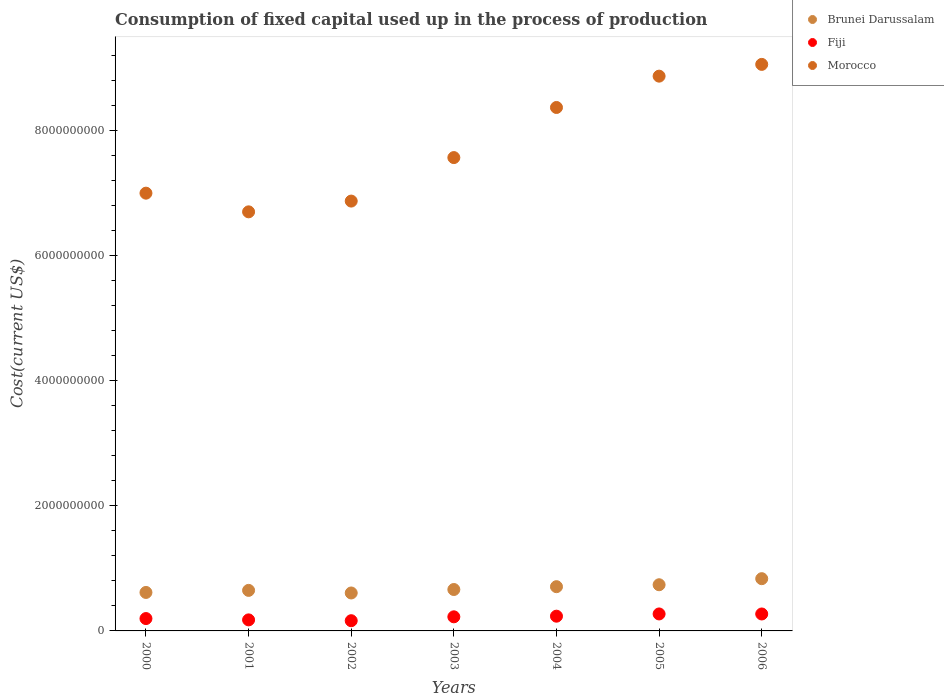How many different coloured dotlines are there?
Offer a terse response. 3. What is the amount consumed in the process of production in Morocco in 2005?
Your response must be concise. 8.88e+09. Across all years, what is the maximum amount consumed in the process of production in Fiji?
Provide a succinct answer. 2.72e+08. Across all years, what is the minimum amount consumed in the process of production in Fiji?
Provide a succinct answer. 1.63e+08. What is the total amount consumed in the process of production in Brunei Darussalam in the graph?
Make the answer very short. 4.82e+09. What is the difference between the amount consumed in the process of production in Brunei Darussalam in 2000 and that in 2004?
Give a very brief answer. -9.22e+07. What is the difference between the amount consumed in the process of production in Fiji in 2003 and the amount consumed in the process of production in Morocco in 2001?
Provide a short and direct response. -6.48e+09. What is the average amount consumed in the process of production in Morocco per year?
Give a very brief answer. 7.78e+09. In the year 2004, what is the difference between the amount consumed in the process of production in Brunei Darussalam and amount consumed in the process of production in Morocco?
Your answer should be compact. -7.67e+09. What is the ratio of the amount consumed in the process of production in Fiji in 2003 to that in 2006?
Your answer should be compact. 0.83. Is the amount consumed in the process of production in Brunei Darussalam in 2001 less than that in 2005?
Provide a short and direct response. Yes. Is the difference between the amount consumed in the process of production in Brunei Darussalam in 2001 and 2002 greater than the difference between the amount consumed in the process of production in Morocco in 2001 and 2002?
Offer a very short reply. Yes. What is the difference between the highest and the second highest amount consumed in the process of production in Brunei Darussalam?
Your response must be concise. 9.71e+07. What is the difference between the highest and the lowest amount consumed in the process of production in Brunei Darussalam?
Offer a very short reply. 2.29e+08. In how many years, is the amount consumed in the process of production in Brunei Darussalam greater than the average amount consumed in the process of production in Brunei Darussalam taken over all years?
Offer a terse response. 3. Is it the case that in every year, the sum of the amount consumed in the process of production in Fiji and amount consumed in the process of production in Brunei Darussalam  is greater than the amount consumed in the process of production in Morocco?
Ensure brevity in your answer.  No. Does the amount consumed in the process of production in Brunei Darussalam monotonically increase over the years?
Your answer should be compact. No. How many dotlines are there?
Keep it short and to the point. 3. How many years are there in the graph?
Give a very brief answer. 7. What is the difference between two consecutive major ticks on the Y-axis?
Make the answer very short. 2.00e+09. Are the values on the major ticks of Y-axis written in scientific E-notation?
Ensure brevity in your answer.  No. Does the graph contain any zero values?
Make the answer very short. No. Does the graph contain grids?
Provide a succinct answer. No. Where does the legend appear in the graph?
Offer a very short reply. Top right. How many legend labels are there?
Your response must be concise. 3. How are the legend labels stacked?
Provide a short and direct response. Vertical. What is the title of the graph?
Your answer should be very brief. Consumption of fixed capital used up in the process of production. What is the label or title of the Y-axis?
Make the answer very short. Cost(current US$). What is the Cost(current US$) in Brunei Darussalam in 2000?
Your answer should be very brief. 6.16e+08. What is the Cost(current US$) in Fiji in 2000?
Provide a succinct answer. 1.98e+08. What is the Cost(current US$) of Morocco in 2000?
Make the answer very short. 7.00e+09. What is the Cost(current US$) of Brunei Darussalam in 2001?
Provide a succinct answer. 6.49e+08. What is the Cost(current US$) of Fiji in 2001?
Make the answer very short. 1.77e+08. What is the Cost(current US$) of Morocco in 2001?
Provide a short and direct response. 6.71e+09. What is the Cost(current US$) of Brunei Darussalam in 2002?
Your answer should be very brief. 6.07e+08. What is the Cost(current US$) of Fiji in 2002?
Offer a terse response. 1.63e+08. What is the Cost(current US$) of Morocco in 2002?
Give a very brief answer. 6.88e+09. What is the Cost(current US$) in Brunei Darussalam in 2003?
Your response must be concise. 6.63e+08. What is the Cost(current US$) of Fiji in 2003?
Keep it short and to the point. 2.26e+08. What is the Cost(current US$) of Morocco in 2003?
Ensure brevity in your answer.  7.57e+09. What is the Cost(current US$) in Brunei Darussalam in 2004?
Keep it short and to the point. 7.08e+08. What is the Cost(current US$) in Fiji in 2004?
Provide a short and direct response. 2.36e+08. What is the Cost(current US$) in Morocco in 2004?
Give a very brief answer. 8.38e+09. What is the Cost(current US$) in Brunei Darussalam in 2005?
Keep it short and to the point. 7.39e+08. What is the Cost(current US$) in Fiji in 2005?
Your answer should be very brief. 2.72e+08. What is the Cost(current US$) of Morocco in 2005?
Provide a succinct answer. 8.88e+09. What is the Cost(current US$) in Brunei Darussalam in 2006?
Offer a very short reply. 8.36e+08. What is the Cost(current US$) in Fiji in 2006?
Keep it short and to the point. 2.71e+08. What is the Cost(current US$) of Morocco in 2006?
Make the answer very short. 9.07e+09. Across all years, what is the maximum Cost(current US$) of Brunei Darussalam?
Your response must be concise. 8.36e+08. Across all years, what is the maximum Cost(current US$) in Fiji?
Provide a succinct answer. 2.72e+08. Across all years, what is the maximum Cost(current US$) of Morocco?
Make the answer very short. 9.07e+09. Across all years, what is the minimum Cost(current US$) of Brunei Darussalam?
Offer a very short reply. 6.07e+08. Across all years, what is the minimum Cost(current US$) in Fiji?
Your response must be concise. 1.63e+08. Across all years, what is the minimum Cost(current US$) of Morocco?
Provide a succinct answer. 6.71e+09. What is the total Cost(current US$) in Brunei Darussalam in the graph?
Give a very brief answer. 4.82e+09. What is the total Cost(current US$) in Fiji in the graph?
Give a very brief answer. 1.54e+09. What is the total Cost(current US$) of Morocco in the graph?
Ensure brevity in your answer.  5.45e+1. What is the difference between the Cost(current US$) in Brunei Darussalam in 2000 and that in 2001?
Your response must be concise. -3.31e+07. What is the difference between the Cost(current US$) of Fiji in 2000 and that in 2001?
Provide a succinct answer. 2.11e+07. What is the difference between the Cost(current US$) in Morocco in 2000 and that in 2001?
Your answer should be compact. 2.99e+08. What is the difference between the Cost(current US$) of Brunei Darussalam in 2000 and that in 2002?
Provide a succinct answer. 8.53e+06. What is the difference between the Cost(current US$) of Fiji in 2000 and that in 2002?
Offer a very short reply. 3.44e+07. What is the difference between the Cost(current US$) of Morocco in 2000 and that in 2002?
Give a very brief answer. 1.27e+08. What is the difference between the Cost(current US$) of Brunei Darussalam in 2000 and that in 2003?
Offer a very short reply. -4.70e+07. What is the difference between the Cost(current US$) of Fiji in 2000 and that in 2003?
Your answer should be very brief. -2.79e+07. What is the difference between the Cost(current US$) in Morocco in 2000 and that in 2003?
Your answer should be very brief. -5.69e+08. What is the difference between the Cost(current US$) in Brunei Darussalam in 2000 and that in 2004?
Keep it short and to the point. -9.22e+07. What is the difference between the Cost(current US$) of Fiji in 2000 and that in 2004?
Give a very brief answer. -3.80e+07. What is the difference between the Cost(current US$) of Morocco in 2000 and that in 2004?
Make the answer very short. -1.37e+09. What is the difference between the Cost(current US$) in Brunei Darussalam in 2000 and that in 2005?
Your response must be concise. -1.23e+08. What is the difference between the Cost(current US$) of Fiji in 2000 and that in 2005?
Your answer should be very brief. -7.39e+07. What is the difference between the Cost(current US$) of Morocco in 2000 and that in 2005?
Your answer should be very brief. -1.87e+09. What is the difference between the Cost(current US$) of Brunei Darussalam in 2000 and that in 2006?
Provide a short and direct response. -2.20e+08. What is the difference between the Cost(current US$) of Fiji in 2000 and that in 2006?
Offer a very short reply. -7.33e+07. What is the difference between the Cost(current US$) in Morocco in 2000 and that in 2006?
Keep it short and to the point. -2.06e+09. What is the difference between the Cost(current US$) in Brunei Darussalam in 2001 and that in 2002?
Offer a very short reply. 4.16e+07. What is the difference between the Cost(current US$) of Fiji in 2001 and that in 2002?
Your answer should be very brief. 1.33e+07. What is the difference between the Cost(current US$) of Morocco in 2001 and that in 2002?
Make the answer very short. -1.72e+08. What is the difference between the Cost(current US$) in Brunei Darussalam in 2001 and that in 2003?
Make the answer very short. -1.40e+07. What is the difference between the Cost(current US$) in Fiji in 2001 and that in 2003?
Your response must be concise. -4.89e+07. What is the difference between the Cost(current US$) of Morocco in 2001 and that in 2003?
Provide a short and direct response. -8.68e+08. What is the difference between the Cost(current US$) of Brunei Darussalam in 2001 and that in 2004?
Offer a terse response. -5.92e+07. What is the difference between the Cost(current US$) in Fiji in 2001 and that in 2004?
Ensure brevity in your answer.  -5.91e+07. What is the difference between the Cost(current US$) in Morocco in 2001 and that in 2004?
Give a very brief answer. -1.67e+09. What is the difference between the Cost(current US$) in Brunei Darussalam in 2001 and that in 2005?
Your answer should be compact. -9.01e+07. What is the difference between the Cost(current US$) of Fiji in 2001 and that in 2005?
Ensure brevity in your answer.  -9.49e+07. What is the difference between the Cost(current US$) in Morocco in 2001 and that in 2005?
Your answer should be very brief. -2.17e+09. What is the difference between the Cost(current US$) in Brunei Darussalam in 2001 and that in 2006?
Offer a very short reply. -1.87e+08. What is the difference between the Cost(current US$) of Fiji in 2001 and that in 2006?
Keep it short and to the point. -9.44e+07. What is the difference between the Cost(current US$) in Morocco in 2001 and that in 2006?
Provide a short and direct response. -2.36e+09. What is the difference between the Cost(current US$) of Brunei Darussalam in 2002 and that in 2003?
Ensure brevity in your answer.  -5.56e+07. What is the difference between the Cost(current US$) of Fiji in 2002 and that in 2003?
Offer a very short reply. -6.22e+07. What is the difference between the Cost(current US$) of Morocco in 2002 and that in 2003?
Provide a short and direct response. -6.96e+08. What is the difference between the Cost(current US$) in Brunei Darussalam in 2002 and that in 2004?
Offer a terse response. -1.01e+08. What is the difference between the Cost(current US$) in Fiji in 2002 and that in 2004?
Provide a short and direct response. -7.24e+07. What is the difference between the Cost(current US$) in Morocco in 2002 and that in 2004?
Ensure brevity in your answer.  -1.50e+09. What is the difference between the Cost(current US$) of Brunei Darussalam in 2002 and that in 2005?
Make the answer very short. -1.32e+08. What is the difference between the Cost(current US$) in Fiji in 2002 and that in 2005?
Your response must be concise. -1.08e+08. What is the difference between the Cost(current US$) in Morocco in 2002 and that in 2005?
Your answer should be very brief. -2.00e+09. What is the difference between the Cost(current US$) of Brunei Darussalam in 2002 and that in 2006?
Your answer should be very brief. -2.29e+08. What is the difference between the Cost(current US$) of Fiji in 2002 and that in 2006?
Keep it short and to the point. -1.08e+08. What is the difference between the Cost(current US$) in Morocco in 2002 and that in 2006?
Provide a succinct answer. -2.19e+09. What is the difference between the Cost(current US$) of Brunei Darussalam in 2003 and that in 2004?
Offer a very short reply. -4.52e+07. What is the difference between the Cost(current US$) in Fiji in 2003 and that in 2004?
Make the answer very short. -1.02e+07. What is the difference between the Cost(current US$) of Morocco in 2003 and that in 2004?
Make the answer very short. -8.02e+08. What is the difference between the Cost(current US$) of Brunei Darussalam in 2003 and that in 2005?
Your answer should be compact. -7.62e+07. What is the difference between the Cost(current US$) of Fiji in 2003 and that in 2005?
Give a very brief answer. -4.60e+07. What is the difference between the Cost(current US$) in Morocco in 2003 and that in 2005?
Your answer should be very brief. -1.30e+09. What is the difference between the Cost(current US$) of Brunei Darussalam in 2003 and that in 2006?
Give a very brief answer. -1.73e+08. What is the difference between the Cost(current US$) in Fiji in 2003 and that in 2006?
Provide a short and direct response. -4.55e+07. What is the difference between the Cost(current US$) in Morocco in 2003 and that in 2006?
Your answer should be compact. -1.49e+09. What is the difference between the Cost(current US$) of Brunei Darussalam in 2004 and that in 2005?
Give a very brief answer. -3.10e+07. What is the difference between the Cost(current US$) of Fiji in 2004 and that in 2005?
Offer a terse response. -3.58e+07. What is the difference between the Cost(current US$) of Morocco in 2004 and that in 2005?
Ensure brevity in your answer.  -5.01e+08. What is the difference between the Cost(current US$) in Brunei Darussalam in 2004 and that in 2006?
Your answer should be compact. -1.28e+08. What is the difference between the Cost(current US$) in Fiji in 2004 and that in 2006?
Your response must be concise. -3.53e+07. What is the difference between the Cost(current US$) of Morocco in 2004 and that in 2006?
Provide a short and direct response. -6.90e+08. What is the difference between the Cost(current US$) of Brunei Darussalam in 2005 and that in 2006?
Offer a very short reply. -9.71e+07. What is the difference between the Cost(current US$) of Fiji in 2005 and that in 2006?
Keep it short and to the point. 5.63e+05. What is the difference between the Cost(current US$) of Morocco in 2005 and that in 2006?
Keep it short and to the point. -1.88e+08. What is the difference between the Cost(current US$) of Brunei Darussalam in 2000 and the Cost(current US$) of Fiji in 2001?
Keep it short and to the point. 4.39e+08. What is the difference between the Cost(current US$) of Brunei Darussalam in 2000 and the Cost(current US$) of Morocco in 2001?
Your response must be concise. -6.09e+09. What is the difference between the Cost(current US$) of Fiji in 2000 and the Cost(current US$) of Morocco in 2001?
Give a very brief answer. -6.51e+09. What is the difference between the Cost(current US$) of Brunei Darussalam in 2000 and the Cost(current US$) of Fiji in 2002?
Give a very brief answer. 4.52e+08. What is the difference between the Cost(current US$) of Brunei Darussalam in 2000 and the Cost(current US$) of Morocco in 2002?
Ensure brevity in your answer.  -6.26e+09. What is the difference between the Cost(current US$) of Fiji in 2000 and the Cost(current US$) of Morocco in 2002?
Your answer should be compact. -6.68e+09. What is the difference between the Cost(current US$) of Brunei Darussalam in 2000 and the Cost(current US$) of Fiji in 2003?
Give a very brief answer. 3.90e+08. What is the difference between the Cost(current US$) in Brunei Darussalam in 2000 and the Cost(current US$) in Morocco in 2003?
Offer a terse response. -6.96e+09. What is the difference between the Cost(current US$) of Fiji in 2000 and the Cost(current US$) of Morocco in 2003?
Provide a succinct answer. -7.38e+09. What is the difference between the Cost(current US$) in Brunei Darussalam in 2000 and the Cost(current US$) in Fiji in 2004?
Keep it short and to the point. 3.80e+08. What is the difference between the Cost(current US$) of Brunei Darussalam in 2000 and the Cost(current US$) of Morocco in 2004?
Keep it short and to the point. -7.76e+09. What is the difference between the Cost(current US$) in Fiji in 2000 and the Cost(current US$) in Morocco in 2004?
Make the answer very short. -8.18e+09. What is the difference between the Cost(current US$) in Brunei Darussalam in 2000 and the Cost(current US$) in Fiji in 2005?
Provide a succinct answer. 3.44e+08. What is the difference between the Cost(current US$) of Brunei Darussalam in 2000 and the Cost(current US$) of Morocco in 2005?
Offer a terse response. -8.26e+09. What is the difference between the Cost(current US$) of Fiji in 2000 and the Cost(current US$) of Morocco in 2005?
Your answer should be very brief. -8.68e+09. What is the difference between the Cost(current US$) in Brunei Darussalam in 2000 and the Cost(current US$) in Fiji in 2006?
Offer a very short reply. 3.45e+08. What is the difference between the Cost(current US$) in Brunei Darussalam in 2000 and the Cost(current US$) in Morocco in 2006?
Offer a very short reply. -8.45e+09. What is the difference between the Cost(current US$) of Fiji in 2000 and the Cost(current US$) of Morocco in 2006?
Provide a short and direct response. -8.87e+09. What is the difference between the Cost(current US$) of Brunei Darussalam in 2001 and the Cost(current US$) of Fiji in 2002?
Offer a terse response. 4.85e+08. What is the difference between the Cost(current US$) in Brunei Darussalam in 2001 and the Cost(current US$) in Morocco in 2002?
Your response must be concise. -6.23e+09. What is the difference between the Cost(current US$) of Fiji in 2001 and the Cost(current US$) of Morocco in 2002?
Offer a terse response. -6.70e+09. What is the difference between the Cost(current US$) in Brunei Darussalam in 2001 and the Cost(current US$) in Fiji in 2003?
Ensure brevity in your answer.  4.23e+08. What is the difference between the Cost(current US$) in Brunei Darussalam in 2001 and the Cost(current US$) in Morocco in 2003?
Give a very brief answer. -6.93e+09. What is the difference between the Cost(current US$) in Fiji in 2001 and the Cost(current US$) in Morocco in 2003?
Provide a short and direct response. -7.40e+09. What is the difference between the Cost(current US$) of Brunei Darussalam in 2001 and the Cost(current US$) of Fiji in 2004?
Give a very brief answer. 4.13e+08. What is the difference between the Cost(current US$) of Brunei Darussalam in 2001 and the Cost(current US$) of Morocco in 2004?
Your answer should be compact. -7.73e+09. What is the difference between the Cost(current US$) in Fiji in 2001 and the Cost(current US$) in Morocco in 2004?
Give a very brief answer. -8.20e+09. What is the difference between the Cost(current US$) in Brunei Darussalam in 2001 and the Cost(current US$) in Fiji in 2005?
Offer a terse response. 3.77e+08. What is the difference between the Cost(current US$) in Brunei Darussalam in 2001 and the Cost(current US$) in Morocco in 2005?
Provide a short and direct response. -8.23e+09. What is the difference between the Cost(current US$) in Fiji in 2001 and the Cost(current US$) in Morocco in 2005?
Provide a succinct answer. -8.70e+09. What is the difference between the Cost(current US$) in Brunei Darussalam in 2001 and the Cost(current US$) in Fiji in 2006?
Ensure brevity in your answer.  3.78e+08. What is the difference between the Cost(current US$) in Brunei Darussalam in 2001 and the Cost(current US$) in Morocco in 2006?
Your answer should be very brief. -8.42e+09. What is the difference between the Cost(current US$) in Fiji in 2001 and the Cost(current US$) in Morocco in 2006?
Give a very brief answer. -8.89e+09. What is the difference between the Cost(current US$) in Brunei Darussalam in 2002 and the Cost(current US$) in Fiji in 2003?
Give a very brief answer. 3.81e+08. What is the difference between the Cost(current US$) in Brunei Darussalam in 2002 and the Cost(current US$) in Morocco in 2003?
Your response must be concise. -6.97e+09. What is the difference between the Cost(current US$) of Fiji in 2002 and the Cost(current US$) of Morocco in 2003?
Give a very brief answer. -7.41e+09. What is the difference between the Cost(current US$) in Brunei Darussalam in 2002 and the Cost(current US$) in Fiji in 2004?
Provide a short and direct response. 3.71e+08. What is the difference between the Cost(current US$) in Brunei Darussalam in 2002 and the Cost(current US$) in Morocco in 2004?
Provide a short and direct response. -7.77e+09. What is the difference between the Cost(current US$) in Fiji in 2002 and the Cost(current US$) in Morocco in 2004?
Keep it short and to the point. -8.21e+09. What is the difference between the Cost(current US$) in Brunei Darussalam in 2002 and the Cost(current US$) in Fiji in 2005?
Offer a very short reply. 3.35e+08. What is the difference between the Cost(current US$) of Brunei Darussalam in 2002 and the Cost(current US$) of Morocco in 2005?
Provide a short and direct response. -8.27e+09. What is the difference between the Cost(current US$) of Fiji in 2002 and the Cost(current US$) of Morocco in 2005?
Provide a succinct answer. -8.71e+09. What is the difference between the Cost(current US$) in Brunei Darussalam in 2002 and the Cost(current US$) in Fiji in 2006?
Your answer should be compact. 3.36e+08. What is the difference between the Cost(current US$) of Brunei Darussalam in 2002 and the Cost(current US$) of Morocco in 2006?
Make the answer very short. -8.46e+09. What is the difference between the Cost(current US$) of Fiji in 2002 and the Cost(current US$) of Morocco in 2006?
Give a very brief answer. -8.90e+09. What is the difference between the Cost(current US$) of Brunei Darussalam in 2003 and the Cost(current US$) of Fiji in 2004?
Your answer should be very brief. 4.27e+08. What is the difference between the Cost(current US$) of Brunei Darussalam in 2003 and the Cost(current US$) of Morocco in 2004?
Ensure brevity in your answer.  -7.71e+09. What is the difference between the Cost(current US$) of Fiji in 2003 and the Cost(current US$) of Morocco in 2004?
Your answer should be very brief. -8.15e+09. What is the difference between the Cost(current US$) of Brunei Darussalam in 2003 and the Cost(current US$) of Fiji in 2005?
Offer a very short reply. 3.91e+08. What is the difference between the Cost(current US$) of Brunei Darussalam in 2003 and the Cost(current US$) of Morocco in 2005?
Provide a short and direct response. -8.21e+09. What is the difference between the Cost(current US$) of Fiji in 2003 and the Cost(current US$) of Morocco in 2005?
Provide a succinct answer. -8.65e+09. What is the difference between the Cost(current US$) in Brunei Darussalam in 2003 and the Cost(current US$) in Fiji in 2006?
Make the answer very short. 3.92e+08. What is the difference between the Cost(current US$) in Brunei Darussalam in 2003 and the Cost(current US$) in Morocco in 2006?
Provide a succinct answer. -8.40e+09. What is the difference between the Cost(current US$) of Fiji in 2003 and the Cost(current US$) of Morocco in 2006?
Ensure brevity in your answer.  -8.84e+09. What is the difference between the Cost(current US$) of Brunei Darussalam in 2004 and the Cost(current US$) of Fiji in 2005?
Give a very brief answer. 4.36e+08. What is the difference between the Cost(current US$) of Brunei Darussalam in 2004 and the Cost(current US$) of Morocco in 2005?
Your answer should be compact. -8.17e+09. What is the difference between the Cost(current US$) in Fiji in 2004 and the Cost(current US$) in Morocco in 2005?
Ensure brevity in your answer.  -8.64e+09. What is the difference between the Cost(current US$) of Brunei Darussalam in 2004 and the Cost(current US$) of Fiji in 2006?
Your answer should be very brief. 4.37e+08. What is the difference between the Cost(current US$) in Brunei Darussalam in 2004 and the Cost(current US$) in Morocco in 2006?
Offer a terse response. -8.36e+09. What is the difference between the Cost(current US$) of Fiji in 2004 and the Cost(current US$) of Morocco in 2006?
Your answer should be compact. -8.83e+09. What is the difference between the Cost(current US$) in Brunei Darussalam in 2005 and the Cost(current US$) in Fiji in 2006?
Ensure brevity in your answer.  4.68e+08. What is the difference between the Cost(current US$) of Brunei Darussalam in 2005 and the Cost(current US$) of Morocco in 2006?
Offer a terse response. -8.33e+09. What is the difference between the Cost(current US$) in Fiji in 2005 and the Cost(current US$) in Morocco in 2006?
Your answer should be very brief. -8.79e+09. What is the average Cost(current US$) of Brunei Darussalam per year?
Offer a terse response. 6.88e+08. What is the average Cost(current US$) of Fiji per year?
Your answer should be very brief. 2.20e+08. What is the average Cost(current US$) in Morocco per year?
Make the answer very short. 7.78e+09. In the year 2000, what is the difference between the Cost(current US$) of Brunei Darussalam and Cost(current US$) of Fiji?
Provide a short and direct response. 4.18e+08. In the year 2000, what is the difference between the Cost(current US$) of Brunei Darussalam and Cost(current US$) of Morocco?
Offer a terse response. -6.39e+09. In the year 2000, what is the difference between the Cost(current US$) of Fiji and Cost(current US$) of Morocco?
Provide a short and direct response. -6.81e+09. In the year 2001, what is the difference between the Cost(current US$) in Brunei Darussalam and Cost(current US$) in Fiji?
Offer a very short reply. 4.72e+08. In the year 2001, what is the difference between the Cost(current US$) of Brunei Darussalam and Cost(current US$) of Morocco?
Your answer should be very brief. -6.06e+09. In the year 2001, what is the difference between the Cost(current US$) in Fiji and Cost(current US$) in Morocco?
Offer a terse response. -6.53e+09. In the year 2002, what is the difference between the Cost(current US$) of Brunei Darussalam and Cost(current US$) of Fiji?
Provide a succinct answer. 4.44e+08. In the year 2002, what is the difference between the Cost(current US$) in Brunei Darussalam and Cost(current US$) in Morocco?
Offer a terse response. -6.27e+09. In the year 2002, what is the difference between the Cost(current US$) of Fiji and Cost(current US$) of Morocco?
Provide a short and direct response. -6.71e+09. In the year 2003, what is the difference between the Cost(current US$) of Brunei Darussalam and Cost(current US$) of Fiji?
Give a very brief answer. 4.37e+08. In the year 2003, what is the difference between the Cost(current US$) in Brunei Darussalam and Cost(current US$) in Morocco?
Offer a terse response. -6.91e+09. In the year 2003, what is the difference between the Cost(current US$) in Fiji and Cost(current US$) in Morocco?
Make the answer very short. -7.35e+09. In the year 2004, what is the difference between the Cost(current US$) in Brunei Darussalam and Cost(current US$) in Fiji?
Your answer should be very brief. 4.72e+08. In the year 2004, what is the difference between the Cost(current US$) in Brunei Darussalam and Cost(current US$) in Morocco?
Keep it short and to the point. -7.67e+09. In the year 2004, what is the difference between the Cost(current US$) in Fiji and Cost(current US$) in Morocco?
Give a very brief answer. -8.14e+09. In the year 2005, what is the difference between the Cost(current US$) of Brunei Darussalam and Cost(current US$) of Fiji?
Ensure brevity in your answer.  4.67e+08. In the year 2005, what is the difference between the Cost(current US$) of Brunei Darussalam and Cost(current US$) of Morocco?
Provide a succinct answer. -8.14e+09. In the year 2005, what is the difference between the Cost(current US$) in Fiji and Cost(current US$) in Morocco?
Offer a very short reply. -8.61e+09. In the year 2006, what is the difference between the Cost(current US$) of Brunei Darussalam and Cost(current US$) of Fiji?
Your answer should be compact. 5.65e+08. In the year 2006, what is the difference between the Cost(current US$) of Brunei Darussalam and Cost(current US$) of Morocco?
Your response must be concise. -8.23e+09. In the year 2006, what is the difference between the Cost(current US$) in Fiji and Cost(current US$) in Morocco?
Your answer should be compact. -8.79e+09. What is the ratio of the Cost(current US$) in Brunei Darussalam in 2000 to that in 2001?
Provide a succinct answer. 0.95. What is the ratio of the Cost(current US$) of Fiji in 2000 to that in 2001?
Keep it short and to the point. 1.12. What is the ratio of the Cost(current US$) of Morocco in 2000 to that in 2001?
Make the answer very short. 1.04. What is the ratio of the Cost(current US$) of Brunei Darussalam in 2000 to that in 2002?
Keep it short and to the point. 1.01. What is the ratio of the Cost(current US$) of Fiji in 2000 to that in 2002?
Keep it short and to the point. 1.21. What is the ratio of the Cost(current US$) in Morocco in 2000 to that in 2002?
Your response must be concise. 1.02. What is the ratio of the Cost(current US$) of Brunei Darussalam in 2000 to that in 2003?
Your answer should be very brief. 0.93. What is the ratio of the Cost(current US$) in Fiji in 2000 to that in 2003?
Give a very brief answer. 0.88. What is the ratio of the Cost(current US$) in Morocco in 2000 to that in 2003?
Provide a short and direct response. 0.92. What is the ratio of the Cost(current US$) of Brunei Darussalam in 2000 to that in 2004?
Your answer should be compact. 0.87. What is the ratio of the Cost(current US$) in Fiji in 2000 to that in 2004?
Make the answer very short. 0.84. What is the ratio of the Cost(current US$) in Morocco in 2000 to that in 2004?
Your answer should be very brief. 0.84. What is the ratio of the Cost(current US$) of Brunei Darussalam in 2000 to that in 2005?
Offer a very short reply. 0.83. What is the ratio of the Cost(current US$) of Fiji in 2000 to that in 2005?
Your answer should be very brief. 0.73. What is the ratio of the Cost(current US$) in Morocco in 2000 to that in 2005?
Offer a very short reply. 0.79. What is the ratio of the Cost(current US$) of Brunei Darussalam in 2000 to that in 2006?
Provide a short and direct response. 0.74. What is the ratio of the Cost(current US$) in Fiji in 2000 to that in 2006?
Keep it short and to the point. 0.73. What is the ratio of the Cost(current US$) in Morocco in 2000 to that in 2006?
Your answer should be compact. 0.77. What is the ratio of the Cost(current US$) in Brunei Darussalam in 2001 to that in 2002?
Your answer should be compact. 1.07. What is the ratio of the Cost(current US$) of Fiji in 2001 to that in 2002?
Provide a succinct answer. 1.08. What is the ratio of the Cost(current US$) in Brunei Darussalam in 2001 to that in 2003?
Your answer should be compact. 0.98. What is the ratio of the Cost(current US$) in Fiji in 2001 to that in 2003?
Your answer should be compact. 0.78. What is the ratio of the Cost(current US$) in Morocco in 2001 to that in 2003?
Keep it short and to the point. 0.89. What is the ratio of the Cost(current US$) in Brunei Darussalam in 2001 to that in 2004?
Your response must be concise. 0.92. What is the ratio of the Cost(current US$) of Fiji in 2001 to that in 2004?
Your response must be concise. 0.75. What is the ratio of the Cost(current US$) in Morocco in 2001 to that in 2004?
Offer a very short reply. 0.8. What is the ratio of the Cost(current US$) in Brunei Darussalam in 2001 to that in 2005?
Offer a terse response. 0.88. What is the ratio of the Cost(current US$) in Fiji in 2001 to that in 2005?
Your response must be concise. 0.65. What is the ratio of the Cost(current US$) of Morocco in 2001 to that in 2005?
Offer a very short reply. 0.76. What is the ratio of the Cost(current US$) of Brunei Darussalam in 2001 to that in 2006?
Ensure brevity in your answer.  0.78. What is the ratio of the Cost(current US$) of Fiji in 2001 to that in 2006?
Make the answer very short. 0.65. What is the ratio of the Cost(current US$) in Morocco in 2001 to that in 2006?
Offer a very short reply. 0.74. What is the ratio of the Cost(current US$) in Brunei Darussalam in 2002 to that in 2003?
Your answer should be compact. 0.92. What is the ratio of the Cost(current US$) of Fiji in 2002 to that in 2003?
Ensure brevity in your answer.  0.72. What is the ratio of the Cost(current US$) in Morocco in 2002 to that in 2003?
Provide a short and direct response. 0.91. What is the ratio of the Cost(current US$) of Brunei Darussalam in 2002 to that in 2004?
Keep it short and to the point. 0.86. What is the ratio of the Cost(current US$) of Fiji in 2002 to that in 2004?
Provide a succinct answer. 0.69. What is the ratio of the Cost(current US$) of Morocco in 2002 to that in 2004?
Your answer should be compact. 0.82. What is the ratio of the Cost(current US$) in Brunei Darussalam in 2002 to that in 2005?
Provide a short and direct response. 0.82. What is the ratio of the Cost(current US$) of Fiji in 2002 to that in 2005?
Provide a succinct answer. 0.6. What is the ratio of the Cost(current US$) of Morocco in 2002 to that in 2005?
Your response must be concise. 0.77. What is the ratio of the Cost(current US$) of Brunei Darussalam in 2002 to that in 2006?
Keep it short and to the point. 0.73. What is the ratio of the Cost(current US$) in Fiji in 2002 to that in 2006?
Your answer should be compact. 0.6. What is the ratio of the Cost(current US$) of Morocco in 2002 to that in 2006?
Provide a short and direct response. 0.76. What is the ratio of the Cost(current US$) in Brunei Darussalam in 2003 to that in 2004?
Make the answer very short. 0.94. What is the ratio of the Cost(current US$) of Fiji in 2003 to that in 2004?
Provide a short and direct response. 0.96. What is the ratio of the Cost(current US$) of Morocco in 2003 to that in 2004?
Offer a terse response. 0.9. What is the ratio of the Cost(current US$) in Brunei Darussalam in 2003 to that in 2005?
Your answer should be compact. 0.9. What is the ratio of the Cost(current US$) in Fiji in 2003 to that in 2005?
Make the answer very short. 0.83. What is the ratio of the Cost(current US$) of Morocco in 2003 to that in 2005?
Offer a very short reply. 0.85. What is the ratio of the Cost(current US$) of Brunei Darussalam in 2003 to that in 2006?
Your response must be concise. 0.79. What is the ratio of the Cost(current US$) of Fiji in 2003 to that in 2006?
Make the answer very short. 0.83. What is the ratio of the Cost(current US$) of Morocco in 2003 to that in 2006?
Offer a terse response. 0.84. What is the ratio of the Cost(current US$) in Brunei Darussalam in 2004 to that in 2005?
Provide a short and direct response. 0.96. What is the ratio of the Cost(current US$) in Fiji in 2004 to that in 2005?
Your answer should be compact. 0.87. What is the ratio of the Cost(current US$) of Morocco in 2004 to that in 2005?
Your answer should be very brief. 0.94. What is the ratio of the Cost(current US$) in Brunei Darussalam in 2004 to that in 2006?
Keep it short and to the point. 0.85. What is the ratio of the Cost(current US$) in Fiji in 2004 to that in 2006?
Give a very brief answer. 0.87. What is the ratio of the Cost(current US$) in Morocco in 2004 to that in 2006?
Ensure brevity in your answer.  0.92. What is the ratio of the Cost(current US$) in Brunei Darussalam in 2005 to that in 2006?
Ensure brevity in your answer.  0.88. What is the ratio of the Cost(current US$) in Morocco in 2005 to that in 2006?
Give a very brief answer. 0.98. What is the difference between the highest and the second highest Cost(current US$) of Brunei Darussalam?
Ensure brevity in your answer.  9.71e+07. What is the difference between the highest and the second highest Cost(current US$) of Fiji?
Provide a succinct answer. 5.63e+05. What is the difference between the highest and the second highest Cost(current US$) of Morocco?
Your response must be concise. 1.88e+08. What is the difference between the highest and the lowest Cost(current US$) of Brunei Darussalam?
Ensure brevity in your answer.  2.29e+08. What is the difference between the highest and the lowest Cost(current US$) of Fiji?
Ensure brevity in your answer.  1.08e+08. What is the difference between the highest and the lowest Cost(current US$) of Morocco?
Offer a terse response. 2.36e+09. 